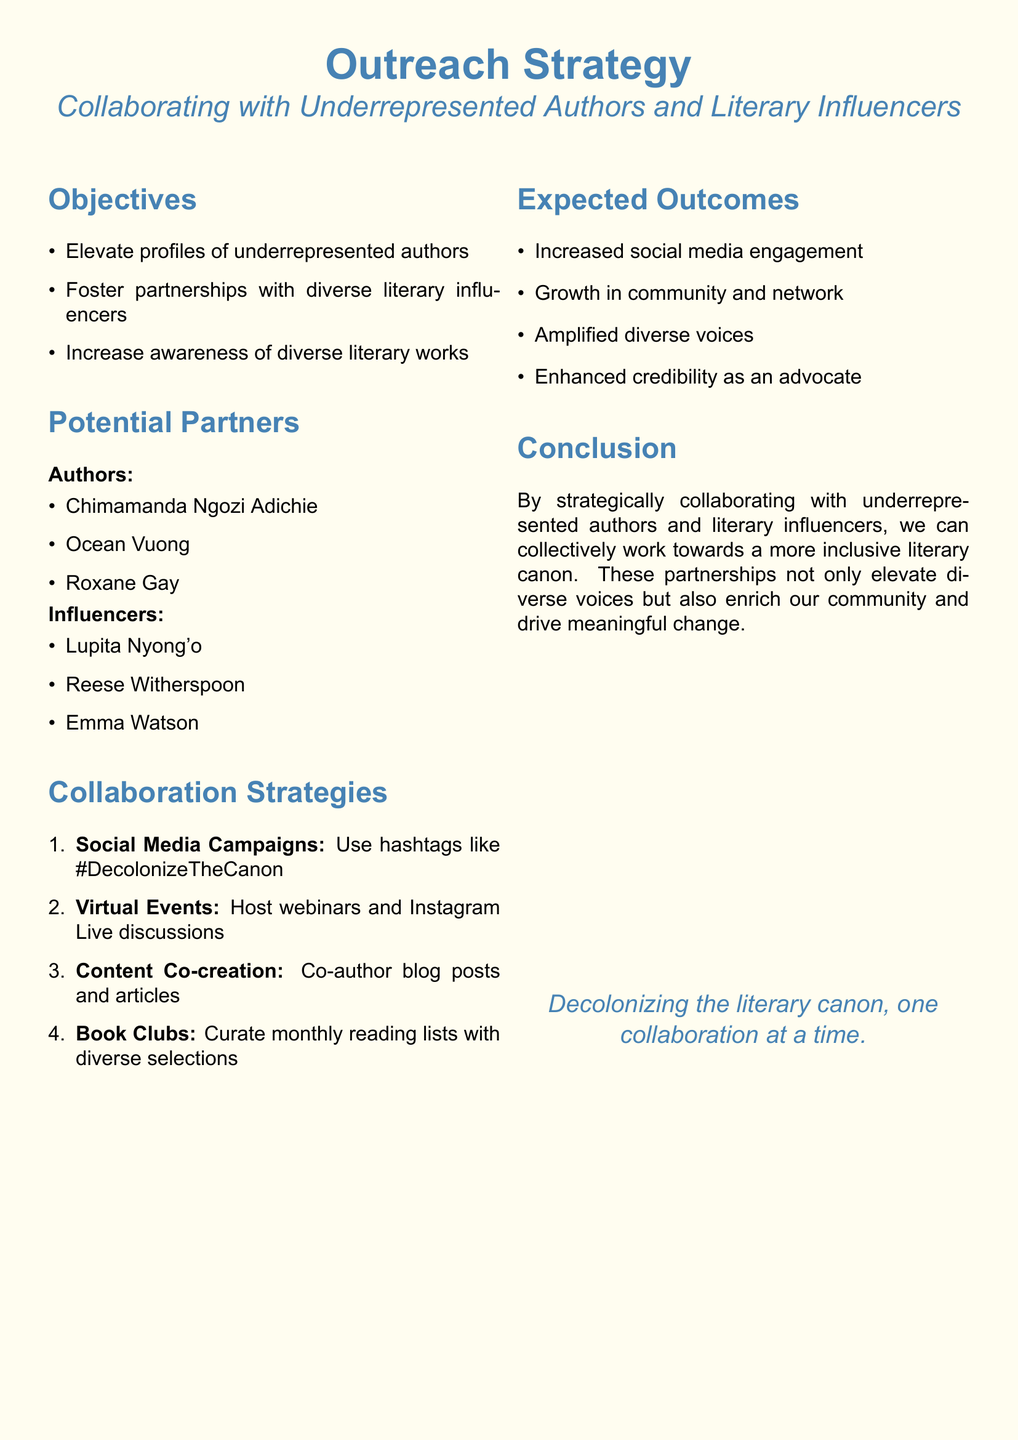What is the primary objective of the outreach strategy? The primary objective is to elevate the profiles of underrepresented authors.
Answer: Elevate profiles of underrepresented authors Who is a potential author partner mentioned in the document? The document lists Chimamanda Ngozi Adichie as a potential author partner.
Answer: Chimamanda Ngozi Adichie What strategic method involves hosting webinars? The method that involves hosting webinars is called Virtual Events.
Answer: Virtual Events What hashtag is suggested for social media campaigns? The suggested hashtag for social media campaigns is #DecolonizeTheCanon.
Answer: #DecolonizeTheCanon What is an expected outcome related to social media? An expected outcome related to social media is increased engagement.
Answer: Increased social media engagement Which influencer is mentioned as a potential partner? The document mentions Lupita Nyong'o as a potential influencer partner.
Answer: Lupita Nyong'o How many collaboration strategies are listed in the document? The document lists a total of four collaboration strategies.
Answer: Four What is emphasized as important to enhance credibility? Amplified diverse voices are emphasized as important for enhancing credibility.
Answer: Amplified diverse voices 